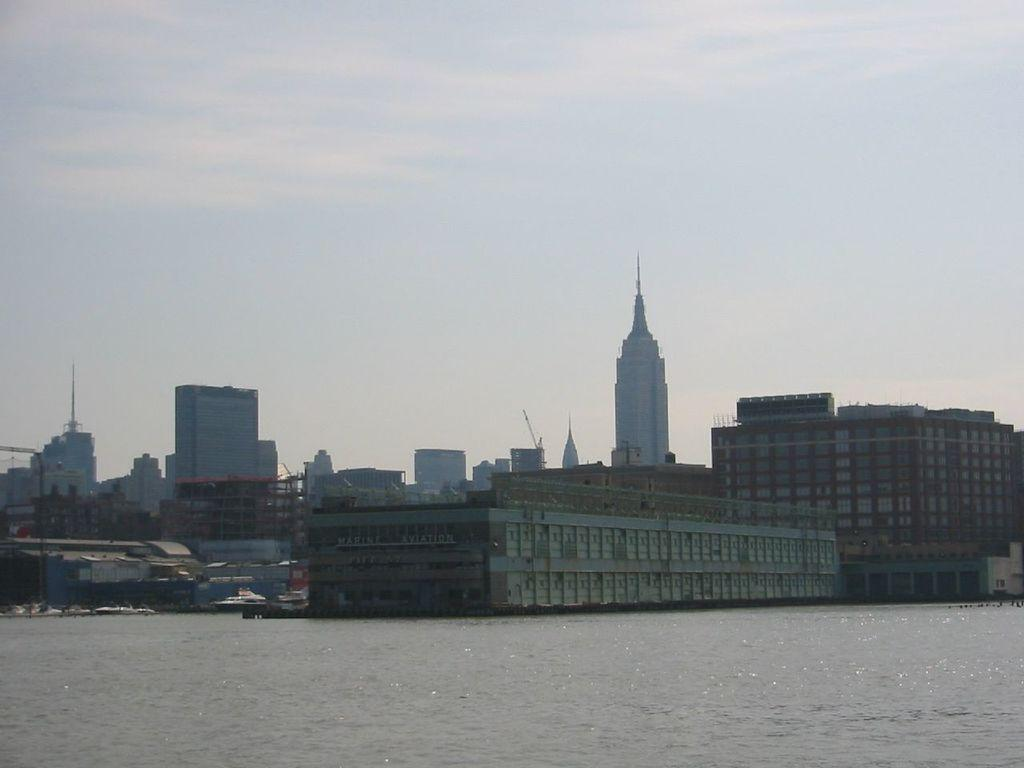What type of natural feature is present in the image? There is a river in the image. What type of man-made structures can be seen in the image? There are buildings in the image. What is visible in the background of the image? The sky is visible in the background of the image. How many boys are visible in the image? There are no boys present in the image. What type of camera is being used to take the picture? There is no camera visible in the image, as it is not a photograph but a scene being described. 